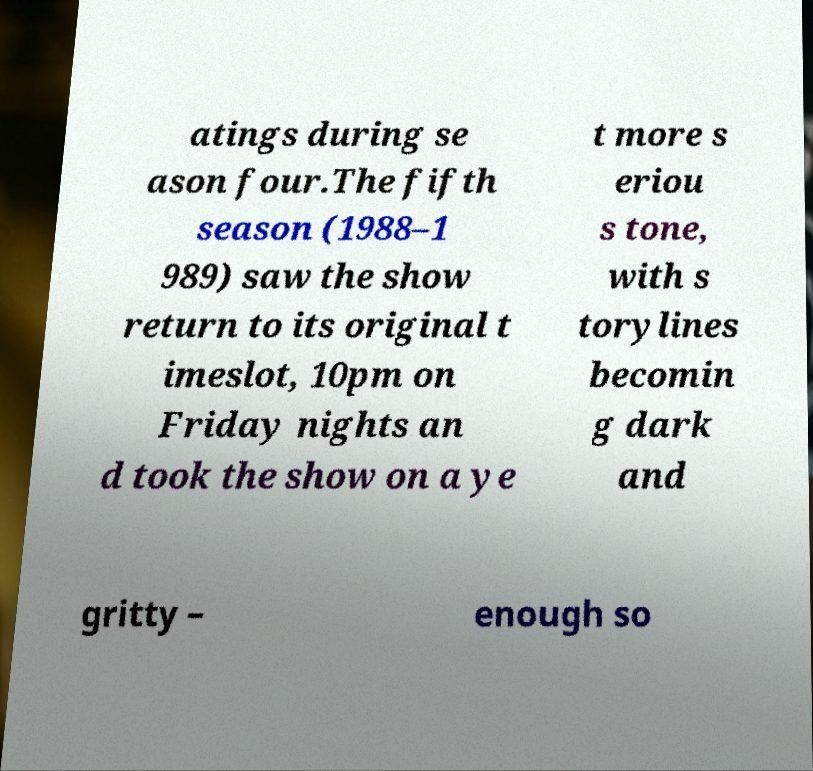There's text embedded in this image that I need extracted. Can you transcribe it verbatim? atings during se ason four.The fifth season (1988–1 989) saw the show return to its original t imeslot, 10pm on Friday nights an d took the show on a ye t more s eriou s tone, with s torylines becomin g dark and gritty – enough so 